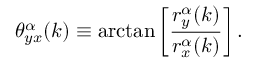Convert formula to latex. <formula><loc_0><loc_0><loc_500><loc_500>\theta _ { y x } ^ { \alpha } ( k ) \equiv \arctan \left [ \frac { r _ { y } ^ { \alpha } ( k ) } { r _ { x } ^ { \alpha } ( k ) } \right ] .</formula> 